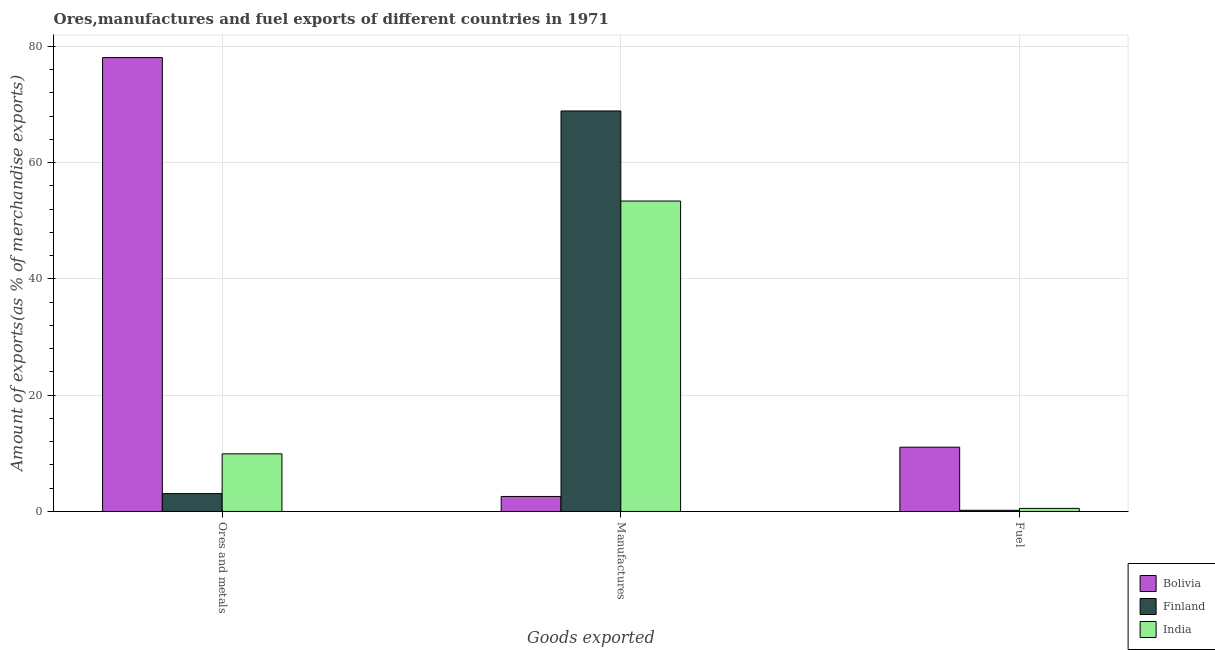How many different coloured bars are there?
Make the answer very short. 3. How many bars are there on the 3rd tick from the left?
Your response must be concise. 3. What is the label of the 3rd group of bars from the left?
Your answer should be very brief. Fuel. What is the percentage of fuel exports in Finland?
Make the answer very short. 0.21. Across all countries, what is the maximum percentage of ores and metals exports?
Offer a very short reply. 78.07. Across all countries, what is the minimum percentage of fuel exports?
Your response must be concise. 0.21. What is the total percentage of manufactures exports in the graph?
Your answer should be very brief. 124.87. What is the difference between the percentage of ores and metals exports in India and that in Bolivia?
Keep it short and to the point. -68.15. What is the difference between the percentage of manufactures exports in Bolivia and the percentage of fuel exports in India?
Your response must be concise. 2.05. What is the average percentage of ores and metals exports per country?
Offer a terse response. 30.35. What is the difference between the percentage of ores and metals exports and percentage of manufactures exports in Bolivia?
Your response must be concise. 75.49. What is the ratio of the percentage of ores and metals exports in Finland to that in Bolivia?
Your answer should be very brief. 0.04. What is the difference between the highest and the second highest percentage of ores and metals exports?
Provide a succinct answer. 68.15. What is the difference between the highest and the lowest percentage of manufactures exports?
Make the answer very short. 66.3. In how many countries, is the percentage of fuel exports greater than the average percentage of fuel exports taken over all countries?
Provide a short and direct response. 1. Is the sum of the percentage of fuel exports in India and Finland greater than the maximum percentage of manufactures exports across all countries?
Provide a succinct answer. No. Is it the case that in every country, the sum of the percentage of ores and metals exports and percentage of manufactures exports is greater than the percentage of fuel exports?
Your response must be concise. Yes. How many countries are there in the graph?
Ensure brevity in your answer.  3. Does the graph contain any zero values?
Your answer should be compact. No. Where does the legend appear in the graph?
Your response must be concise. Bottom right. What is the title of the graph?
Offer a terse response. Ores,manufactures and fuel exports of different countries in 1971. Does "Cameroon" appear as one of the legend labels in the graph?
Your answer should be very brief. No. What is the label or title of the X-axis?
Provide a succinct answer. Goods exported. What is the label or title of the Y-axis?
Offer a very short reply. Amount of exports(as % of merchandise exports). What is the Amount of exports(as % of merchandise exports) of Bolivia in Ores and metals?
Ensure brevity in your answer.  78.07. What is the Amount of exports(as % of merchandise exports) in Finland in Ores and metals?
Your response must be concise. 3.07. What is the Amount of exports(as % of merchandise exports) in India in Ores and metals?
Offer a terse response. 9.92. What is the Amount of exports(as % of merchandise exports) of Bolivia in Manufactures?
Your response must be concise. 2.58. What is the Amount of exports(as % of merchandise exports) in Finland in Manufactures?
Give a very brief answer. 68.89. What is the Amount of exports(as % of merchandise exports) in India in Manufactures?
Provide a succinct answer. 53.4. What is the Amount of exports(as % of merchandise exports) in Bolivia in Fuel?
Make the answer very short. 11.06. What is the Amount of exports(as % of merchandise exports) of Finland in Fuel?
Make the answer very short. 0.21. What is the Amount of exports(as % of merchandise exports) in India in Fuel?
Keep it short and to the point. 0.54. Across all Goods exported, what is the maximum Amount of exports(as % of merchandise exports) of Bolivia?
Provide a succinct answer. 78.07. Across all Goods exported, what is the maximum Amount of exports(as % of merchandise exports) of Finland?
Offer a terse response. 68.89. Across all Goods exported, what is the maximum Amount of exports(as % of merchandise exports) in India?
Make the answer very short. 53.4. Across all Goods exported, what is the minimum Amount of exports(as % of merchandise exports) in Bolivia?
Offer a terse response. 2.58. Across all Goods exported, what is the minimum Amount of exports(as % of merchandise exports) in Finland?
Provide a short and direct response. 0.21. Across all Goods exported, what is the minimum Amount of exports(as % of merchandise exports) in India?
Keep it short and to the point. 0.54. What is the total Amount of exports(as % of merchandise exports) in Bolivia in the graph?
Keep it short and to the point. 91.71. What is the total Amount of exports(as % of merchandise exports) in Finland in the graph?
Provide a succinct answer. 72.17. What is the total Amount of exports(as % of merchandise exports) of India in the graph?
Provide a succinct answer. 63.85. What is the difference between the Amount of exports(as % of merchandise exports) in Bolivia in Ores and metals and that in Manufactures?
Offer a very short reply. 75.49. What is the difference between the Amount of exports(as % of merchandise exports) of Finland in Ores and metals and that in Manufactures?
Provide a succinct answer. -65.81. What is the difference between the Amount of exports(as % of merchandise exports) in India in Ores and metals and that in Manufactures?
Ensure brevity in your answer.  -43.48. What is the difference between the Amount of exports(as % of merchandise exports) of Bolivia in Ores and metals and that in Fuel?
Give a very brief answer. 67.01. What is the difference between the Amount of exports(as % of merchandise exports) of Finland in Ores and metals and that in Fuel?
Give a very brief answer. 2.87. What is the difference between the Amount of exports(as % of merchandise exports) in India in Ores and metals and that in Fuel?
Your answer should be compact. 9.38. What is the difference between the Amount of exports(as % of merchandise exports) of Bolivia in Manufactures and that in Fuel?
Provide a succinct answer. -8.48. What is the difference between the Amount of exports(as % of merchandise exports) in Finland in Manufactures and that in Fuel?
Your answer should be very brief. 68.68. What is the difference between the Amount of exports(as % of merchandise exports) of India in Manufactures and that in Fuel?
Ensure brevity in your answer.  52.86. What is the difference between the Amount of exports(as % of merchandise exports) in Bolivia in Ores and metals and the Amount of exports(as % of merchandise exports) in Finland in Manufactures?
Your answer should be compact. 9.18. What is the difference between the Amount of exports(as % of merchandise exports) of Bolivia in Ores and metals and the Amount of exports(as % of merchandise exports) of India in Manufactures?
Your answer should be compact. 24.67. What is the difference between the Amount of exports(as % of merchandise exports) of Finland in Ores and metals and the Amount of exports(as % of merchandise exports) of India in Manufactures?
Provide a short and direct response. -50.32. What is the difference between the Amount of exports(as % of merchandise exports) in Bolivia in Ores and metals and the Amount of exports(as % of merchandise exports) in Finland in Fuel?
Provide a succinct answer. 77.86. What is the difference between the Amount of exports(as % of merchandise exports) in Bolivia in Ores and metals and the Amount of exports(as % of merchandise exports) in India in Fuel?
Make the answer very short. 77.53. What is the difference between the Amount of exports(as % of merchandise exports) of Finland in Ores and metals and the Amount of exports(as % of merchandise exports) of India in Fuel?
Your answer should be very brief. 2.54. What is the difference between the Amount of exports(as % of merchandise exports) in Bolivia in Manufactures and the Amount of exports(as % of merchandise exports) in Finland in Fuel?
Ensure brevity in your answer.  2.38. What is the difference between the Amount of exports(as % of merchandise exports) in Bolivia in Manufactures and the Amount of exports(as % of merchandise exports) in India in Fuel?
Provide a succinct answer. 2.05. What is the difference between the Amount of exports(as % of merchandise exports) of Finland in Manufactures and the Amount of exports(as % of merchandise exports) of India in Fuel?
Give a very brief answer. 68.35. What is the average Amount of exports(as % of merchandise exports) of Bolivia per Goods exported?
Your answer should be very brief. 30.57. What is the average Amount of exports(as % of merchandise exports) in Finland per Goods exported?
Give a very brief answer. 24.06. What is the average Amount of exports(as % of merchandise exports) of India per Goods exported?
Your answer should be very brief. 21.28. What is the difference between the Amount of exports(as % of merchandise exports) of Bolivia and Amount of exports(as % of merchandise exports) of Finland in Ores and metals?
Offer a very short reply. 75. What is the difference between the Amount of exports(as % of merchandise exports) of Bolivia and Amount of exports(as % of merchandise exports) of India in Ores and metals?
Offer a terse response. 68.15. What is the difference between the Amount of exports(as % of merchandise exports) of Finland and Amount of exports(as % of merchandise exports) of India in Ores and metals?
Your response must be concise. -6.84. What is the difference between the Amount of exports(as % of merchandise exports) in Bolivia and Amount of exports(as % of merchandise exports) in Finland in Manufactures?
Make the answer very short. -66.3. What is the difference between the Amount of exports(as % of merchandise exports) in Bolivia and Amount of exports(as % of merchandise exports) in India in Manufactures?
Provide a succinct answer. -50.81. What is the difference between the Amount of exports(as % of merchandise exports) of Finland and Amount of exports(as % of merchandise exports) of India in Manufactures?
Provide a short and direct response. 15.49. What is the difference between the Amount of exports(as % of merchandise exports) of Bolivia and Amount of exports(as % of merchandise exports) of Finland in Fuel?
Provide a succinct answer. 10.85. What is the difference between the Amount of exports(as % of merchandise exports) in Bolivia and Amount of exports(as % of merchandise exports) in India in Fuel?
Offer a terse response. 10.52. What is the difference between the Amount of exports(as % of merchandise exports) in Finland and Amount of exports(as % of merchandise exports) in India in Fuel?
Make the answer very short. -0.33. What is the ratio of the Amount of exports(as % of merchandise exports) of Bolivia in Ores and metals to that in Manufactures?
Offer a very short reply. 30.22. What is the ratio of the Amount of exports(as % of merchandise exports) in Finland in Ores and metals to that in Manufactures?
Make the answer very short. 0.04. What is the ratio of the Amount of exports(as % of merchandise exports) in India in Ores and metals to that in Manufactures?
Offer a terse response. 0.19. What is the ratio of the Amount of exports(as % of merchandise exports) in Bolivia in Ores and metals to that in Fuel?
Provide a short and direct response. 7.06. What is the ratio of the Amount of exports(as % of merchandise exports) in Finland in Ores and metals to that in Fuel?
Your answer should be very brief. 14.96. What is the ratio of the Amount of exports(as % of merchandise exports) of India in Ores and metals to that in Fuel?
Provide a succinct answer. 18.49. What is the ratio of the Amount of exports(as % of merchandise exports) in Bolivia in Manufactures to that in Fuel?
Your response must be concise. 0.23. What is the ratio of the Amount of exports(as % of merchandise exports) of Finland in Manufactures to that in Fuel?
Provide a succinct answer. 335.17. What is the ratio of the Amount of exports(as % of merchandise exports) in India in Manufactures to that in Fuel?
Offer a terse response. 99.55. What is the difference between the highest and the second highest Amount of exports(as % of merchandise exports) in Bolivia?
Provide a short and direct response. 67.01. What is the difference between the highest and the second highest Amount of exports(as % of merchandise exports) of Finland?
Provide a short and direct response. 65.81. What is the difference between the highest and the second highest Amount of exports(as % of merchandise exports) in India?
Provide a succinct answer. 43.48. What is the difference between the highest and the lowest Amount of exports(as % of merchandise exports) in Bolivia?
Provide a succinct answer. 75.49. What is the difference between the highest and the lowest Amount of exports(as % of merchandise exports) of Finland?
Your response must be concise. 68.68. What is the difference between the highest and the lowest Amount of exports(as % of merchandise exports) of India?
Make the answer very short. 52.86. 